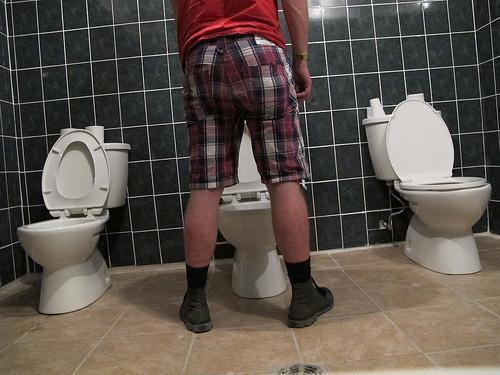How many toilets are shown?
Give a very brief answer. 3. 